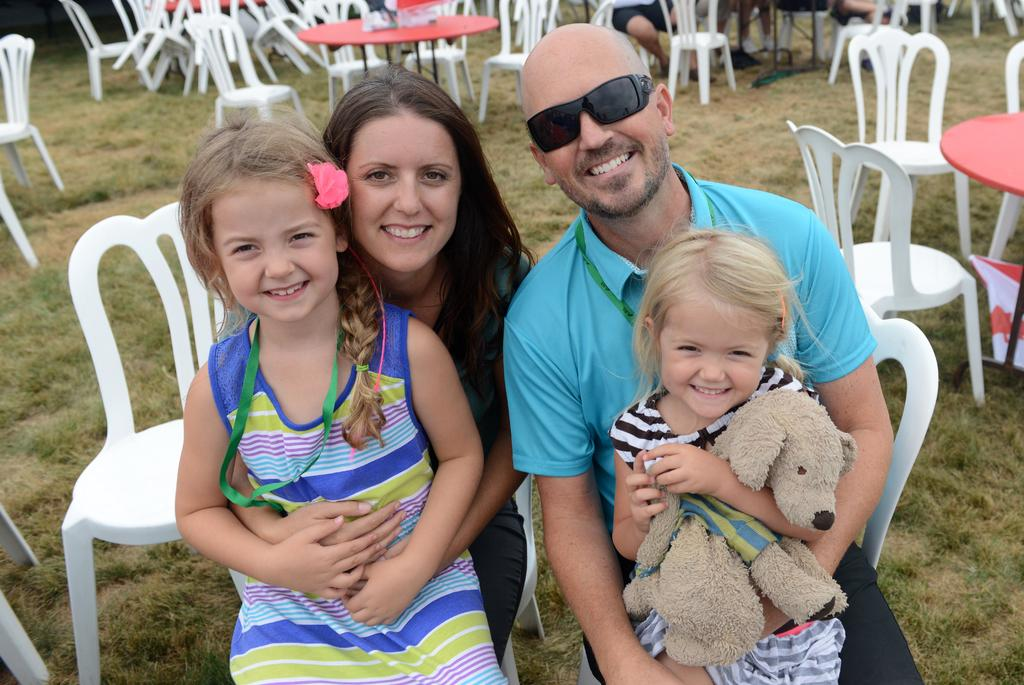What are the persons in the image doing? The persons in the image are sitting on chairs and holding a child. What else can be seen in the image besides the persons and the child? There is a doll, tables, chairs, and other objects present in the image. Reasoning: Let's think step by step by step in order to produce the conversation. We start by identifying the main action taking place in the image, which is the persons holding a child. Then, we expand the conversation to include other objects and subjects that are also visible, such as the doll, tables, chairs, and other objects. Each question is designed to elicit a specific detail about the image that is known from the provided facts. Absurd Question/Answer: What type of treatment is being administered to the child in the image? There is no treatment being administered to the child in the image; the persons are simply holding the child. What books are the persons reading to the child in the image? There are no books present in the image. What type of organization is the child a member of in the image? There is no indication in the image that the child is a member of any organization. What books are the persons reading to the child in the image? There are no books present in the image. 